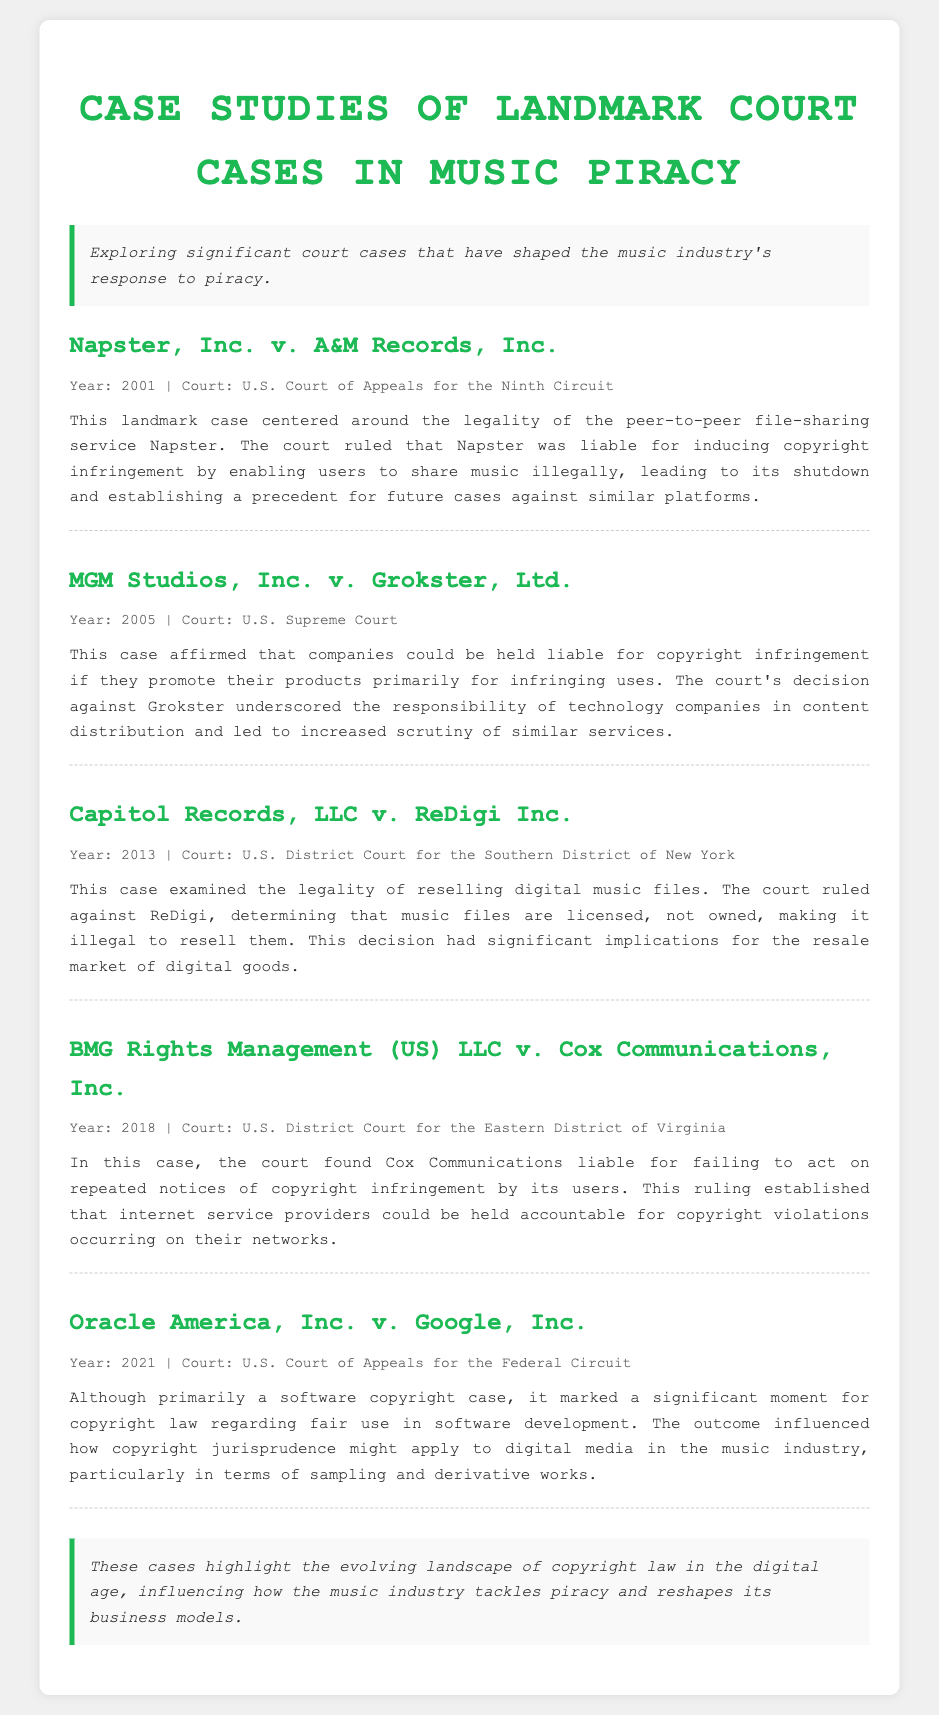What was the year of the Napster case? The document explicitly states the year of the Napster, Inc. v. A&M Records, Inc. case is 2001.
Answer: 2001 Who was found liable in the MGM Studios case? The document mentions that the decision was against Grokster, indicating they were found liable.
Answer: Grokster What court ruled in the ReDigi case? The document specifies that the case Capitol Records, LLC v. ReDigi Inc. was ruled by the U.S. District Court for the Southern District of New York.
Answer: U.S. District Court for the Southern District of New York What was the ruling regarding digital music files in the ReDigi case? According to the document, the court ruled that music files are licensed, not owned, which makes it illegal to resell them.
Answer: Illegal to resell Which case addressed the responsibility of internet service providers? The document highlights the BMG Rights Management (US) LLC v. Cox Communications case regarding the liability of internet service providers.
Answer: BMG Rights Management (US) LLC v. Cox Communications What was a key effect of the Oracle America case mentioned? The document notes that the Oracle America, Inc. v. Google, Inc. case influenced how copyright jurisprudence might apply to digital media in the music industry.
Answer: Influenced copyright jurisprudence What conclusion is drawn about copyright law in the document? The document concludes that the cases highlight the evolving landscape of copyright law in the digital age.
Answer: Evolving landscape of copyright law What does the summary of the Napster case indicate about its impact? The case's summary states that it established a precedent for future cases against similar platforms, indicating its significant impact.
Answer: Established a precedent What year did the Cox Communications case occur? The document provides that this case occurred in 2018.
Answer: 2018 